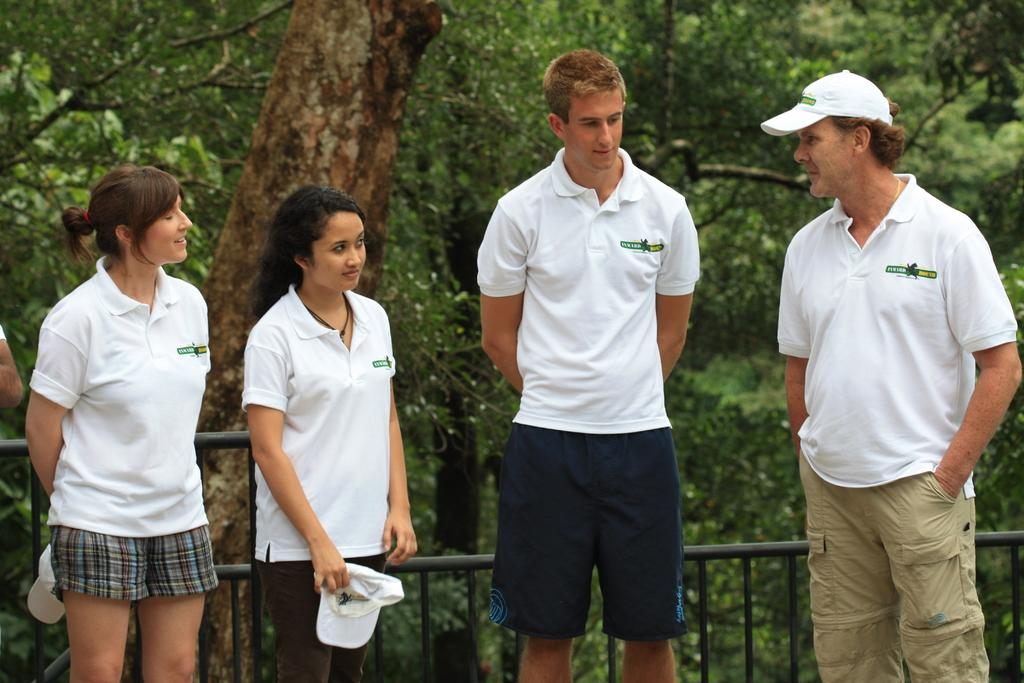How many people are in the image? There are four persons in the image. What are the persons doing in the image? The persons are standing. What are the persons wearing in the image? The persons are wearing white T-shirts. What is located behind the persons in the image? There is a fence behind the persons. What can be seen in the background of the image? There are trees in the background of the image. What is the cause of the building's collapse in the image? There is no building present in the image, so it is not possible to determine the cause of any collapse. 